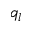Convert formula to latex. <formula><loc_0><loc_0><loc_500><loc_500>q _ { l }</formula> 